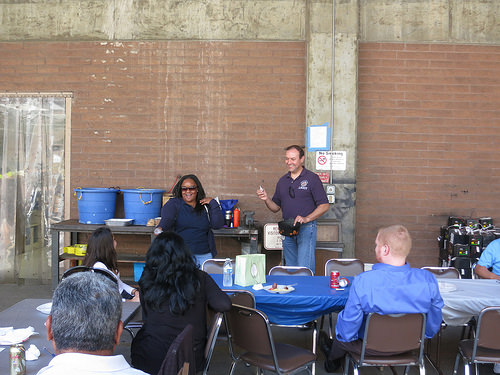<image>
Is the man to the left of the lady? Yes. From this viewpoint, the man is positioned to the left side relative to the lady. Where is the man in relation to the women? Is it to the left of the women? No. The man is not to the left of the women. From this viewpoint, they have a different horizontal relationship. 